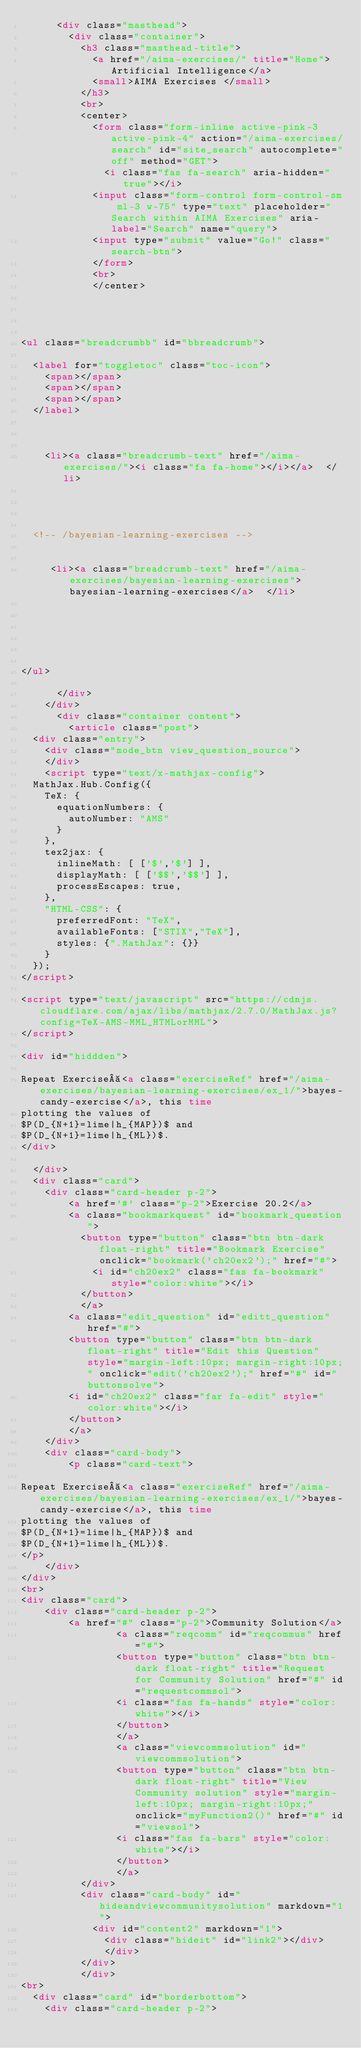Convert code to text. <code><loc_0><loc_0><loc_500><loc_500><_HTML_>      <div class="masthead">
        <div class="container">
          <h3 class="masthead-title">
            <a href="/aima-exercises/" title="Home">Artificial Intelligence</a>
            <small>AIMA Exercises </small>
          </h3>
          <br>
          <center>
            <form class="form-inline active-pink-3 active-pink-4" action="/aima-exercises/search" id="site_search" autocomplete="off" method="GET">
              <i class="fas fa-search" aria-hidden="true"></i>
            <input class="form-control form-control-sm ml-3 w-75" type="text" placeholder="Search within AIMA Exercises" aria-label="Search" name="query">
            <input type="submit" value="Go!" class="search-btn">
            </form>
            <br>
            </center>
            



<ul class="breadcrumbb" id="bbreadcrumb">

  <label for="toggletoc" class="toc-icon">
    <span></span>
    <span></span>
    <span></span>
  </label>

   
   
    <li><a class="breadcrumb-text" href="/aima-exercises/"><i class="fa fa-home"></i></a>  </li>

    
     
     
  <!-- /bayesian-learning-exercises -->
  
  
     <li><a class="breadcrumb-text" href="/aima-exercises/bayesian-learning-exercises">bayesian-learning-exercises</a>  </li>

     
    
   


</ul>

      </div>
    </div>
      <div class="container content">
        <article class="post">
  <div class="entry">
    <div class="mode_btn view_question_source">
    </div>
    <script type="text/x-mathjax-config">
  MathJax.Hub.Config({
    TeX: {
      equationNumbers: {
        autoNumber: "AMS"
      }
    },
    tex2jax: {
      inlineMath: [ ['$','$'] ],
      displayMath: [ ['$$','$$'] ],
      processEscapes: true,
    },
    "HTML-CSS": { 
      preferredFont: "TeX", 
      availableFonts: ["STIX","TeX"], 
      styles: {".MathJax": {}} 
    }
  });
</script>

<script type="text/javascript" src="https://cdnjs.cloudflare.com/ajax/libs/mathjax/2.7.0/MathJax.js?config=TeX-AMS-MML_HTMLorMML">
</script>

<div id="hiddden">

Repeat Exercise <a class="exerciseRef" href="/aima-exercises/bayesian-learning-exercises/ex_1/">bayes-candy-exercise</a>, this time
plotting the values of
$P(D_{N+1}=lime|h_{MAP})$ and
$P(D_{N+1}=lime|h_{ML})$.
</div>

  </div>
  <div class="card">
    <div class="card-header p-2">
        <a href='#' class="p-2">Exercise 20.2</a>
        <a class="bookmarkquest" id="bookmark_question">
          <button type="button" class="btn btn-dark float-right" title="Bookmark Exercise" onclick="bookmark('ch20ex2');" href="#">
            <i id="ch20ex2" class="fas fa-bookmark" style="color:white"></i>
          </button>
          </a>
        <a class="edit_question" id="editt_question" href="#">
        <button type="button" class="btn btn-dark float-right" title="Edit this Question" style="margin-left:10px; margin-right:10px;" onclick="edit('ch20ex2');" href="#" id="buttonsolve">
        <i id="ch20ex2" class="far fa-edit" style="color:white"></i>
        </button>
        </a>
    </div>
    <div class="card-body">
        <p class="card-text">

Repeat Exercise <a class="exerciseRef" href="/aima-exercises/bayesian-learning-exercises/ex_1/">bayes-candy-exercise</a>, this time
plotting the values of
$P(D_{N+1}=lime|h_{MAP})$ and
$P(D_{N+1}=lime|h_{ML})$.
</p>
    </div>
</div>
<br>
<div class="card">
    <div class="card-header p-2">
        <a href="#" class="p-2">Community Solution</a>
                <a class="reqcomm" id="reqcommus" href="#">
                <button type="button" class="btn btn-dark float-right" title="Request for Community Solution" href="#" id="requestcommsol">
                <i class="fas fa-hands" style="color:white"></i>
                </button>
                </a>
                <a class="viewcommsolution" id="viewcommsolution">
                <button type="button" class="btn btn-dark float-right" title="View Community solution" style="margin-left:10px; margin-right:10px;" onclick="myFunction2()" href="#" id="viewsol">
                <i class="fas fa-bars" style="color:white"></i>
                </button>
                </a>
          </div>
          <div class="card-body" id="hideandviewcommunitysolution" markdown="1">
            <div id="content2" markdown="1">
              <div class="hideit" id="link2"></div>
              </div>
          </div>
          </div>
<br>
  <div class="card" id="borderbottom">
    <div class="card-header p-2"></code> 